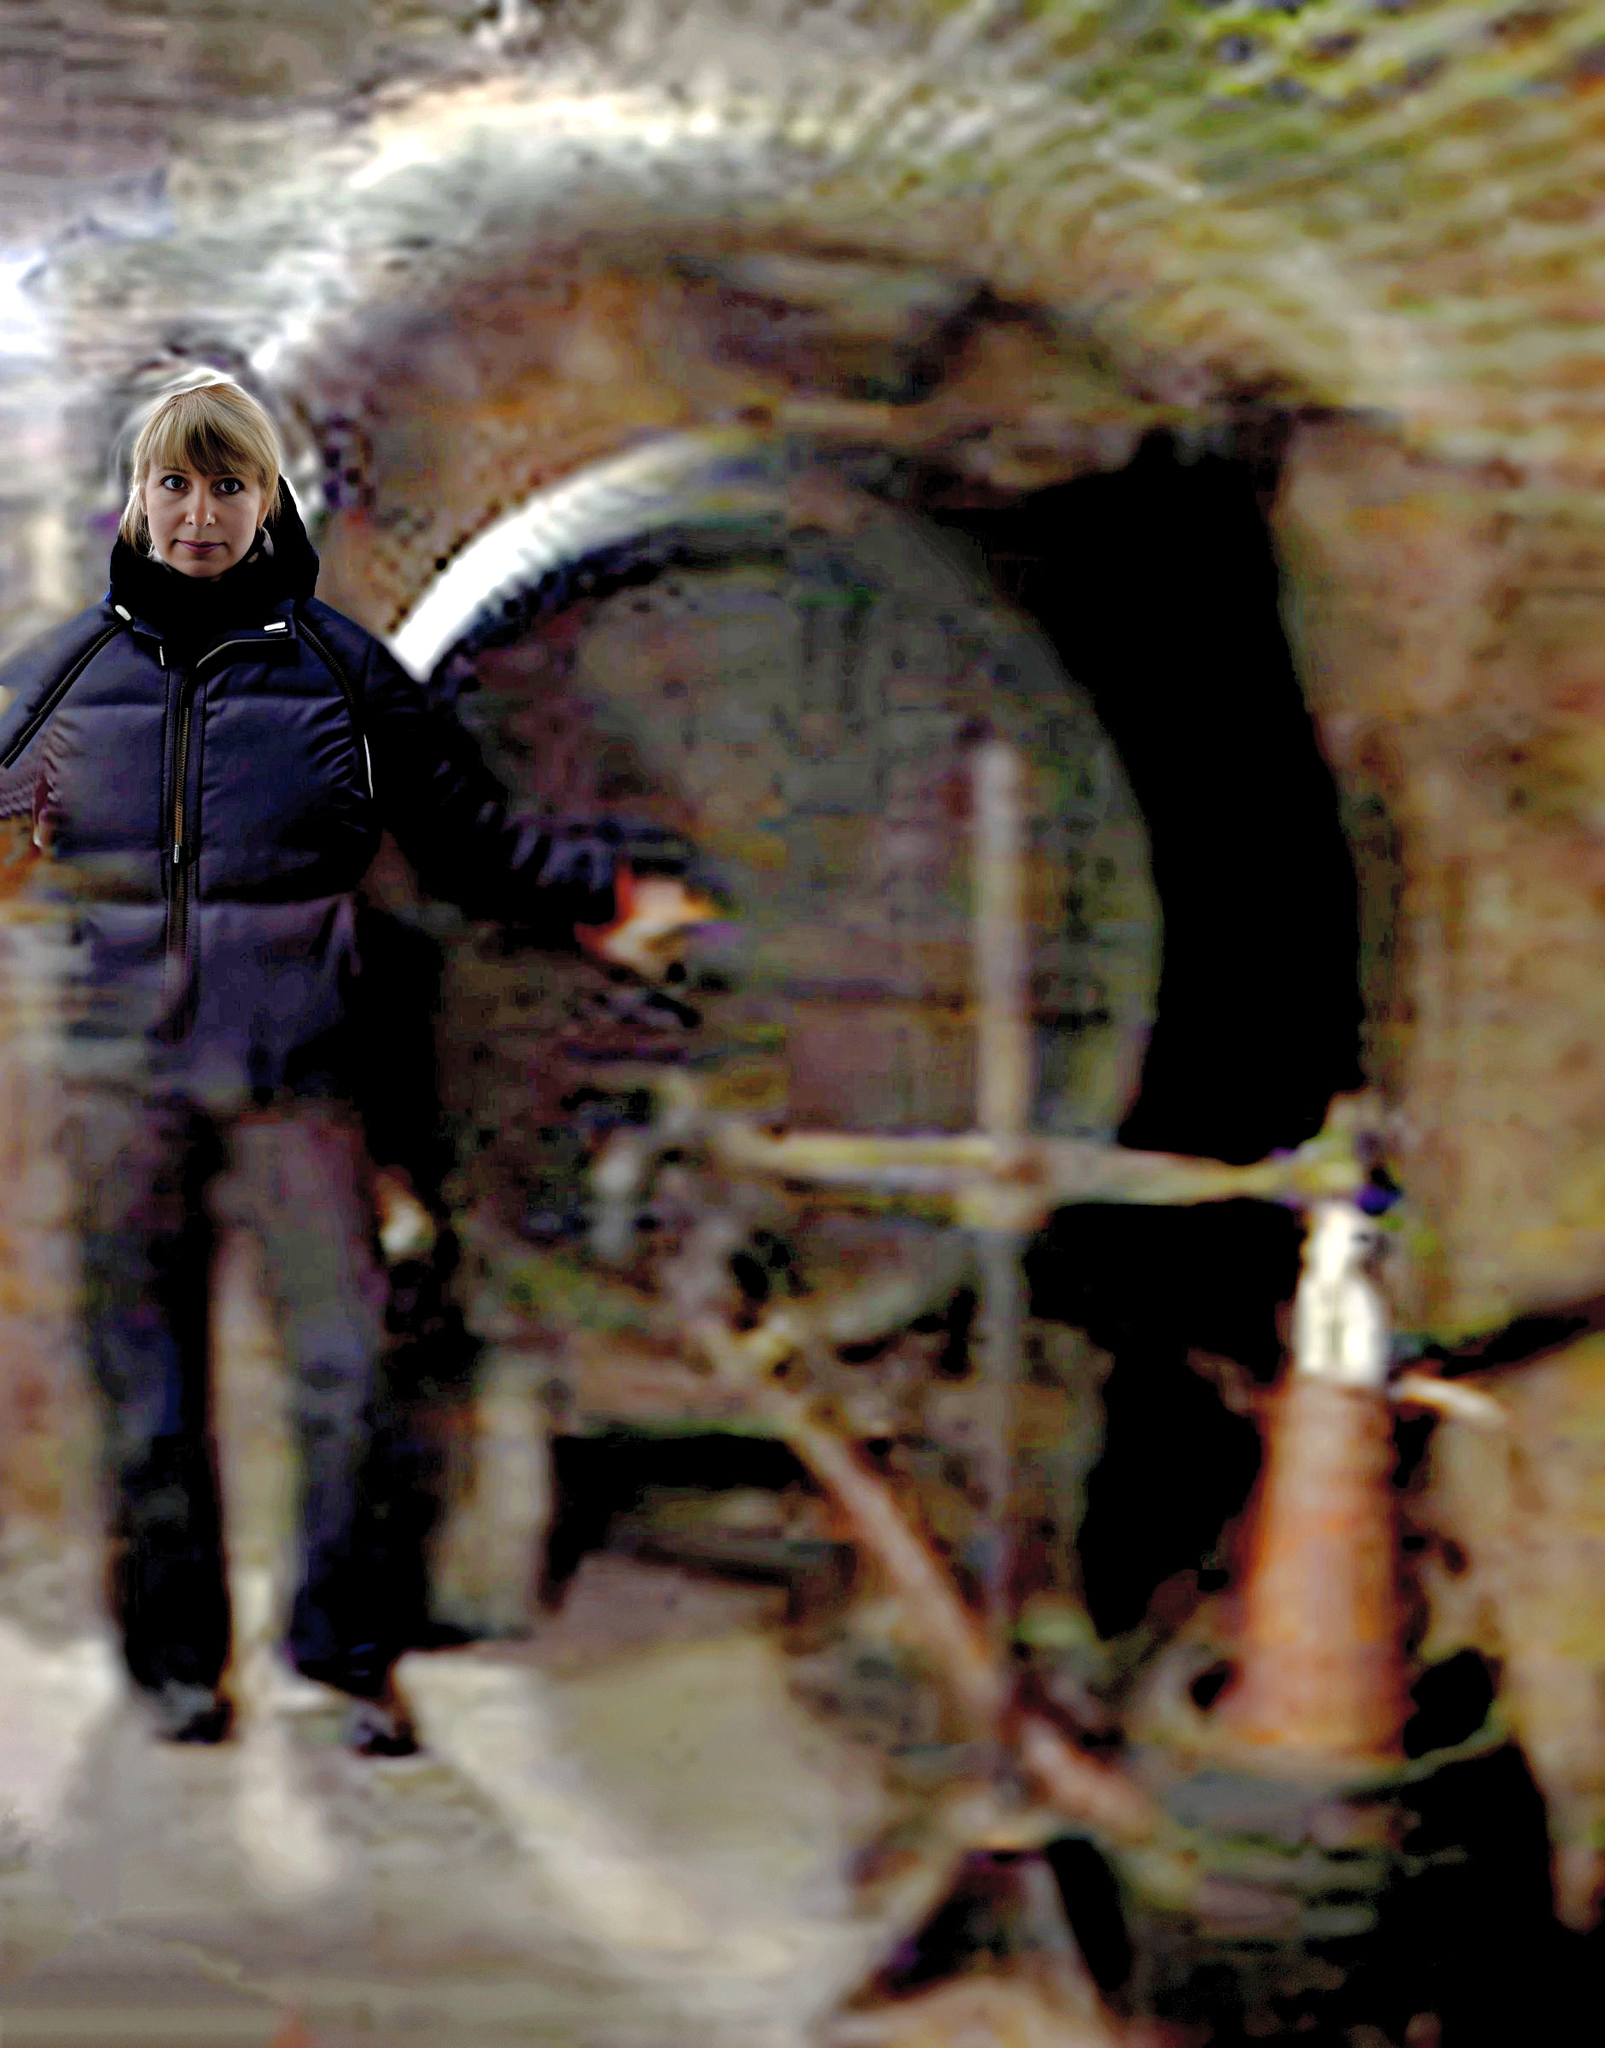describe
 The image is of a woman standing in front of a dark, shadowy doorway. She is wearing a dark winter coat, and her face is partially obscured by the hood. The doorway is dimly lit, and it is difficult to make out what is on the other side. The image is out of focus, giving it a dreamlike quality. The overall tone of the image is dark and mysterious. 